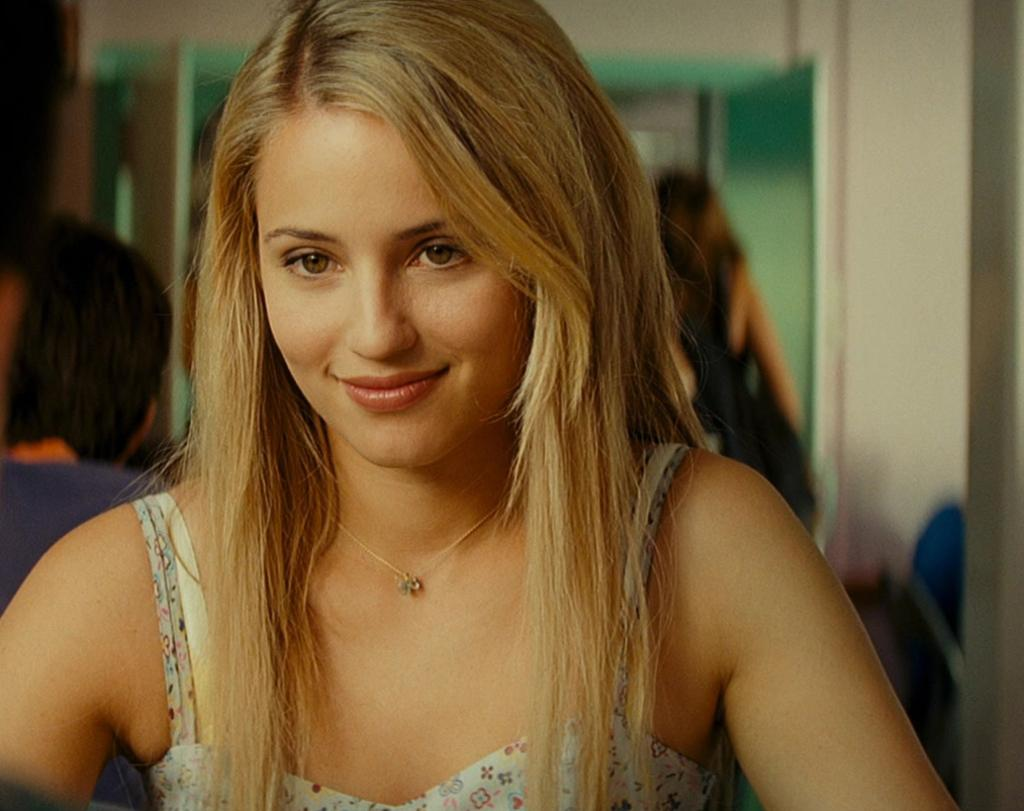Where was the image taken? The image is taken indoors. What can be seen in the background of the image? There is a wall in the background of the image, and there are a few people visible as well. Who is the main subject in the image? The main subject in the image is a girl. How is the girl's expression in the image? The girl has a smiling face in the image. What is the water level in the stream visible in the image? There is no stream present in the image; it was taken indoors. 